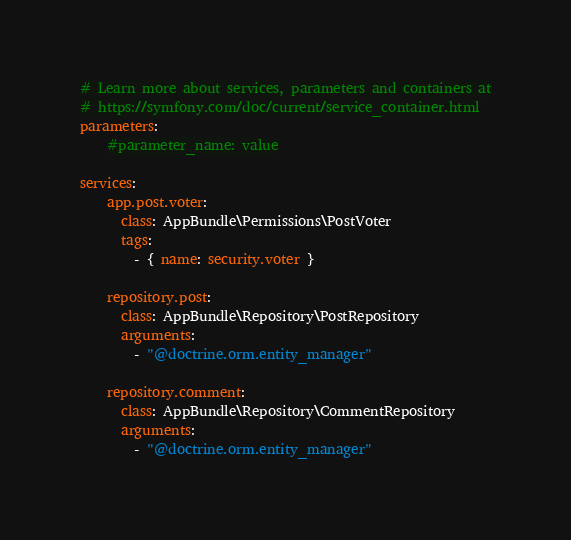<code> <loc_0><loc_0><loc_500><loc_500><_YAML_># Learn more about services, parameters and containers at
# https://symfony.com/doc/current/service_container.html
parameters:
    #parameter_name: value

services:
    app.post.voter:
      class: AppBundle\Permissions\PostVoter
      tags:
        - { name: security.voter }

    repository.post:
      class: AppBundle\Repository\PostRepository
      arguments:
        - "@doctrine.orm.entity_manager"

    repository.comment:
      class: AppBundle\Repository\CommentRepository
      arguments:
        - "@doctrine.orm.entity_manager"

</code> 